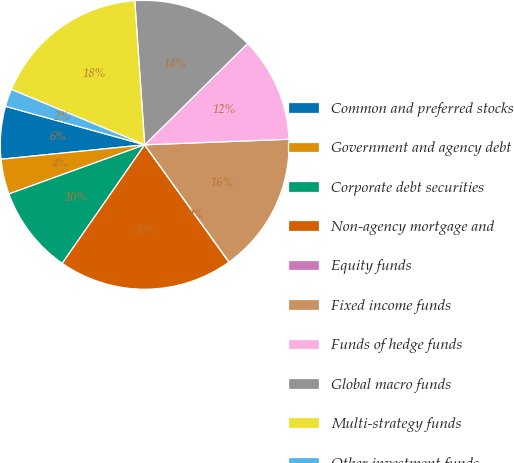Convert chart. <chart><loc_0><loc_0><loc_500><loc_500><pie_chart><fcel>Common and preferred stocks<fcel>Government and agency debt<fcel>Corporate debt securities<fcel>Non-agency mortgage and<fcel>Equity funds<fcel>Fixed income funds<fcel>Funds of hedge funds<fcel>Global macro funds<fcel>Multi-strategy funds<fcel>Other investment funds<nl><fcel>5.89%<fcel>3.93%<fcel>9.8%<fcel>19.6%<fcel>0.01%<fcel>15.68%<fcel>11.76%<fcel>13.72%<fcel>17.64%<fcel>1.97%<nl></chart> 